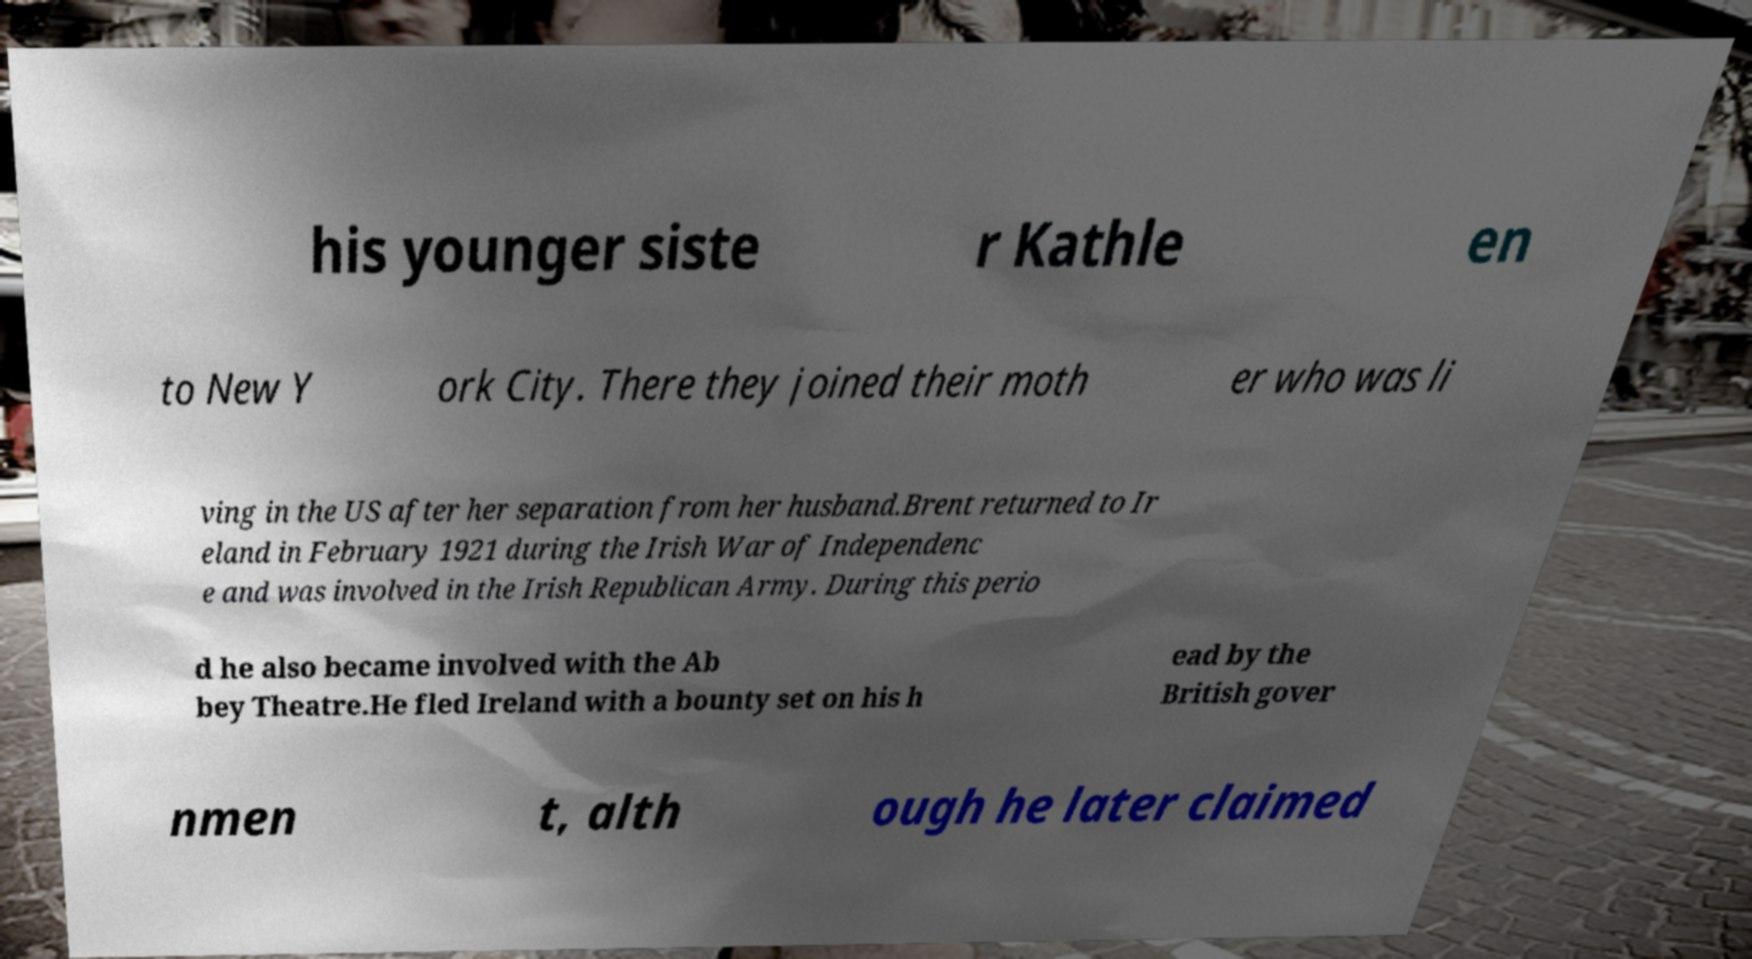There's text embedded in this image that I need extracted. Can you transcribe it verbatim? his younger siste r Kathle en to New Y ork City. There they joined their moth er who was li ving in the US after her separation from her husband.Brent returned to Ir eland in February 1921 during the Irish War of Independenc e and was involved in the Irish Republican Army. During this perio d he also became involved with the Ab bey Theatre.He fled Ireland with a bounty set on his h ead by the British gover nmen t, alth ough he later claimed 